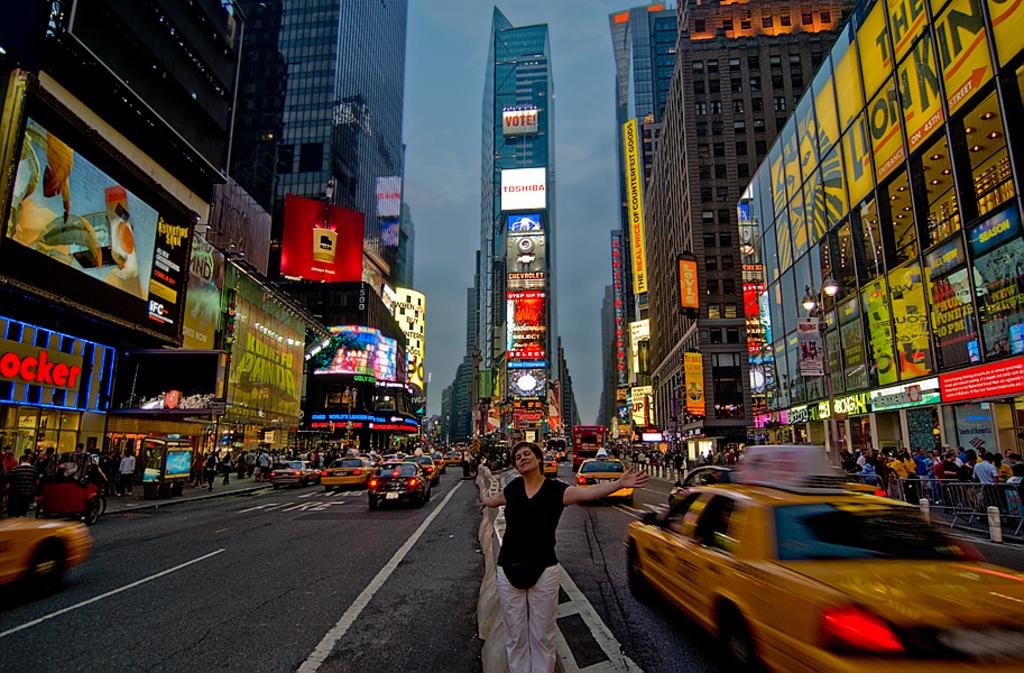What does it say on the top sign on the building in the middle?
Your answer should be compact. Vote. 